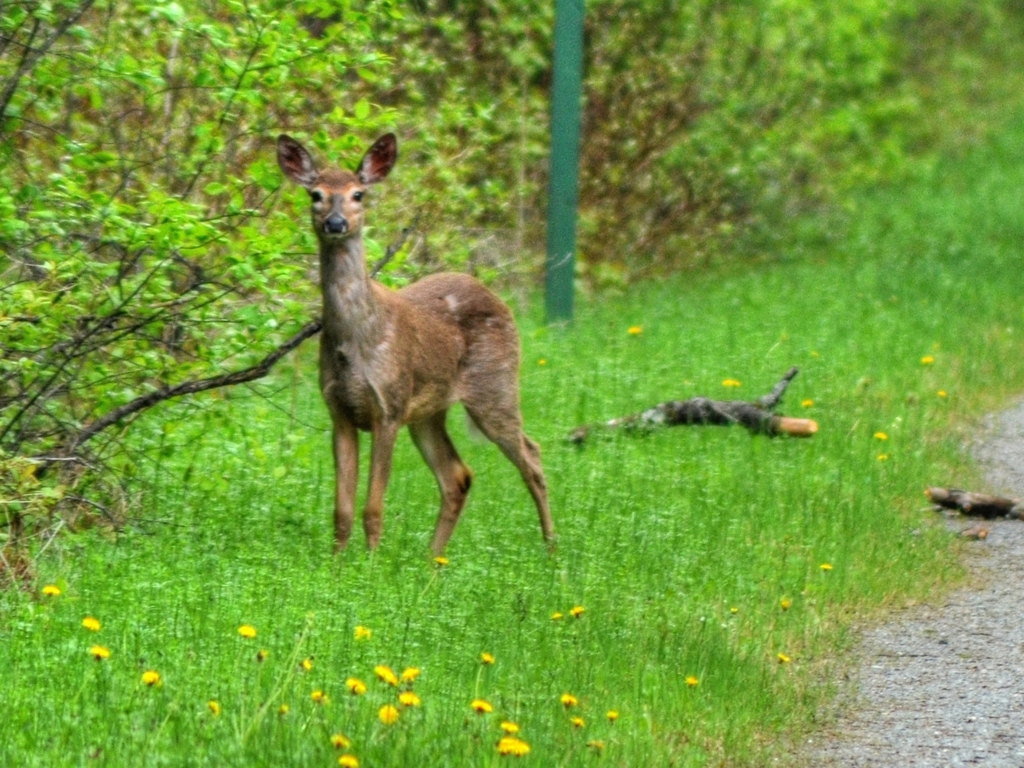This setting looks peaceful. What might this area be, and why would a deer be here? The image shows a deer in a lush, green area that seems to be a path through woods or a nature reserve. The plethora of green foliage suggests it could be spring or summer. Deer are commonly found in such environments because they offer abundant food sources like leaves, grasses, and flowers, as well as cover from predators. The presence of dandelions suggests a meadow-like area nearby, which is an ideal grazing spot for deer. 